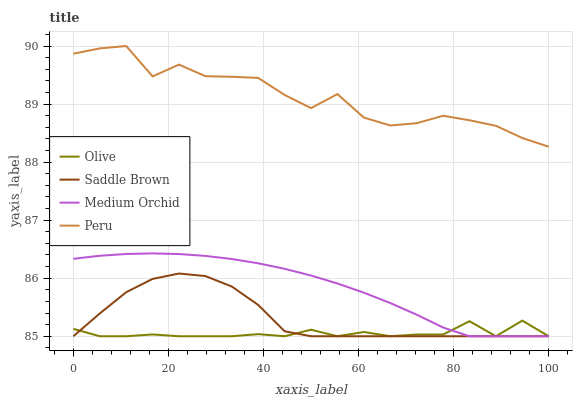Does Olive have the minimum area under the curve?
Answer yes or no. Yes. Does Peru have the maximum area under the curve?
Answer yes or no. Yes. Does Medium Orchid have the minimum area under the curve?
Answer yes or no. No. Does Medium Orchid have the maximum area under the curve?
Answer yes or no. No. Is Medium Orchid the smoothest?
Answer yes or no. Yes. Is Peru the roughest?
Answer yes or no. Yes. Is Saddle Brown the smoothest?
Answer yes or no. No. Is Saddle Brown the roughest?
Answer yes or no. No. Does Peru have the lowest value?
Answer yes or no. No. Does Peru have the highest value?
Answer yes or no. Yes. Does Medium Orchid have the highest value?
Answer yes or no. No. Is Medium Orchid less than Peru?
Answer yes or no. Yes. Is Peru greater than Medium Orchid?
Answer yes or no. Yes. Does Medium Orchid intersect Peru?
Answer yes or no. No. 